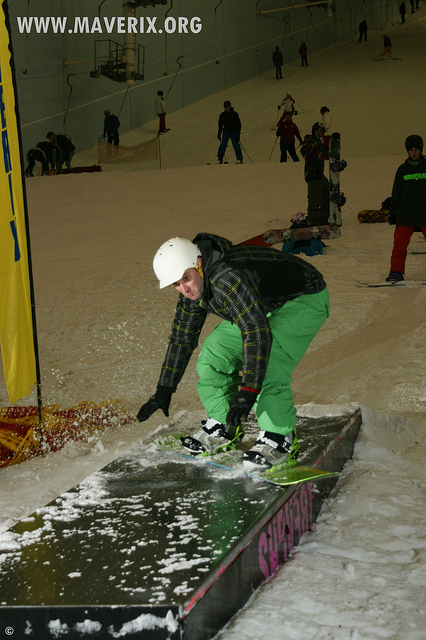Please extract the text content from this image. WWW.MAVERIX.ORG 